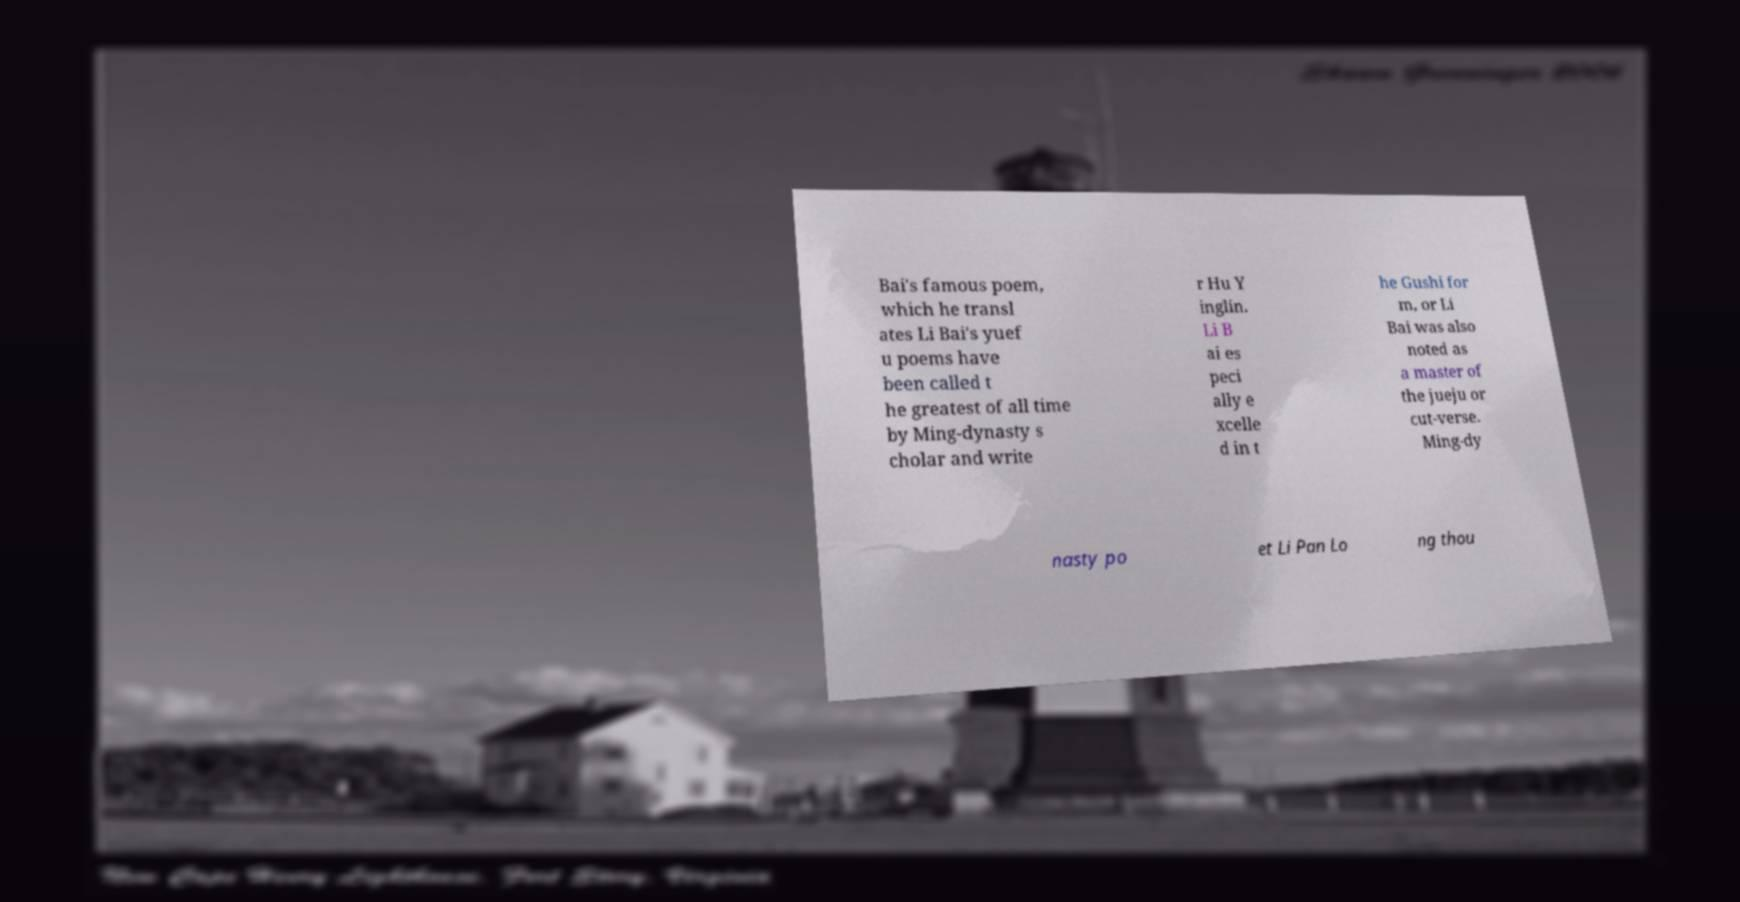Please read and relay the text visible in this image. What does it say? Bai's famous poem, which he transl ates Li Bai's yuef u poems have been called t he greatest of all time by Ming-dynasty s cholar and write r Hu Y inglin. Li B ai es peci ally e xcelle d in t he Gushi for m, or Li Bai was also noted as a master of the jueju or cut-verse. Ming-dy nasty po et Li Pan Lo ng thou 